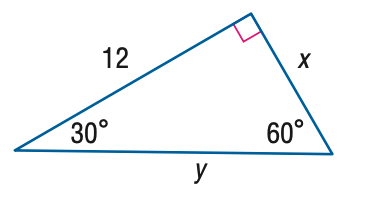Answer the mathemtical geometry problem and directly provide the correct option letter.
Question: Find x.
Choices: A: 4 B: 6 C: 4 \sqrt { 3 } D: 8 \sqrt { 3 } C 